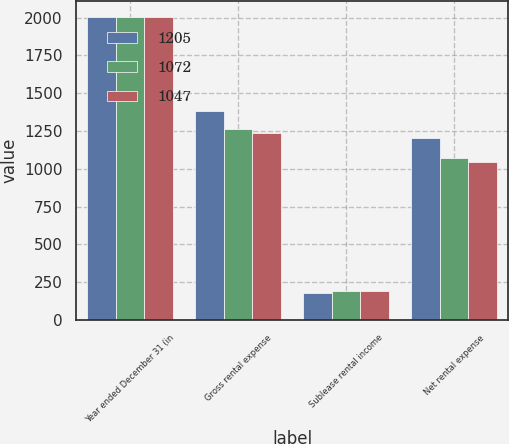Convert chart to OTSL. <chart><loc_0><loc_0><loc_500><loc_500><stacked_bar_chart><ecel><fcel>Year ended December 31 (in<fcel>Gross rental expense<fcel>Sublease rental income<fcel>Net rental expense<nl><fcel>1205<fcel>2007<fcel>1380<fcel>175<fcel>1205<nl><fcel>1072<fcel>2006<fcel>1266<fcel>194<fcel>1072<nl><fcel>1047<fcel>2005<fcel>1239<fcel>192<fcel>1047<nl></chart> 